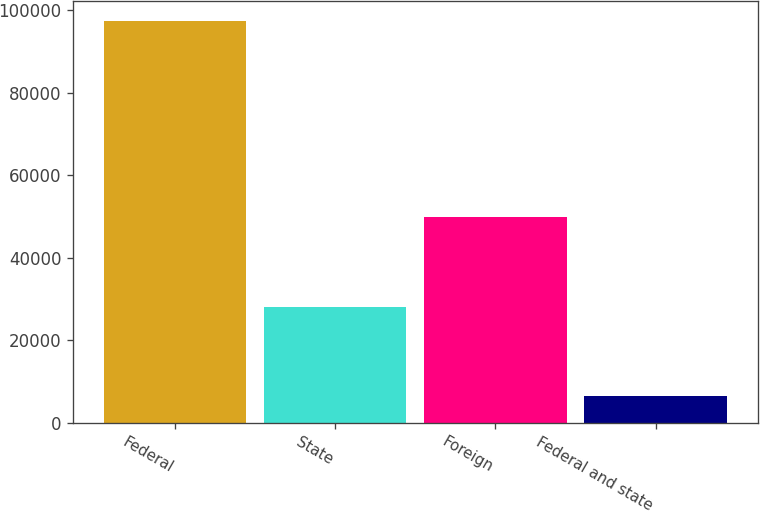Convert chart. <chart><loc_0><loc_0><loc_500><loc_500><bar_chart><fcel>Federal<fcel>State<fcel>Foreign<fcel>Federal and state<nl><fcel>97262<fcel>28046<fcel>49830<fcel>6569<nl></chart> 